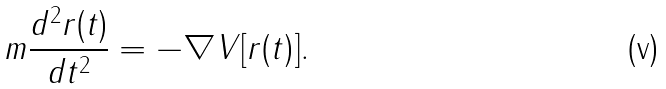Convert formula to latex. <formula><loc_0><loc_0><loc_500><loc_500>m { \frac { d ^ { 2 } r ( t ) } { d t ^ { 2 } } } = - \nabla V [ r ( t ) ] .</formula> 